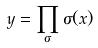<formula> <loc_0><loc_0><loc_500><loc_500>y = \prod _ { \sigma } \sigma ( x )</formula> 